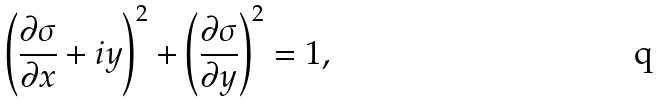Convert formula to latex. <formula><loc_0><loc_0><loc_500><loc_500>\left ( \frac { \partial \sigma } { \partial x } + i y \right ) ^ { 2 } + \left ( \frac { \partial \sigma } { \partial y } \right ) ^ { 2 } = 1 ,</formula> 